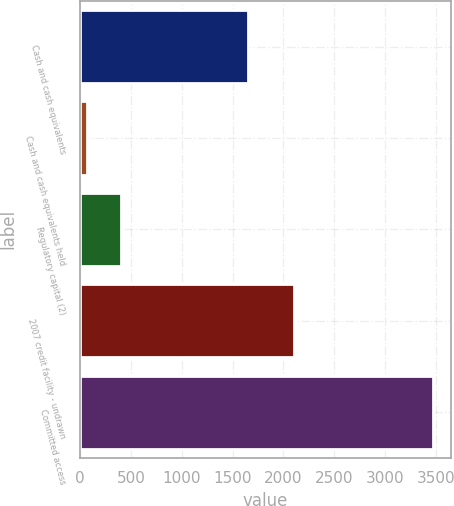Convert chart to OTSL. <chart><loc_0><loc_0><loc_500><loc_500><bar_chart><fcel>Cash and cash equivalents<fcel>Cash and cash equivalents held<fcel>Regulatory capital (2)<fcel>2007 credit facility - undrawn<fcel>Committed access<nl><fcel>1656<fcel>67<fcel>407.5<fcel>2100<fcel>3472<nl></chart> 